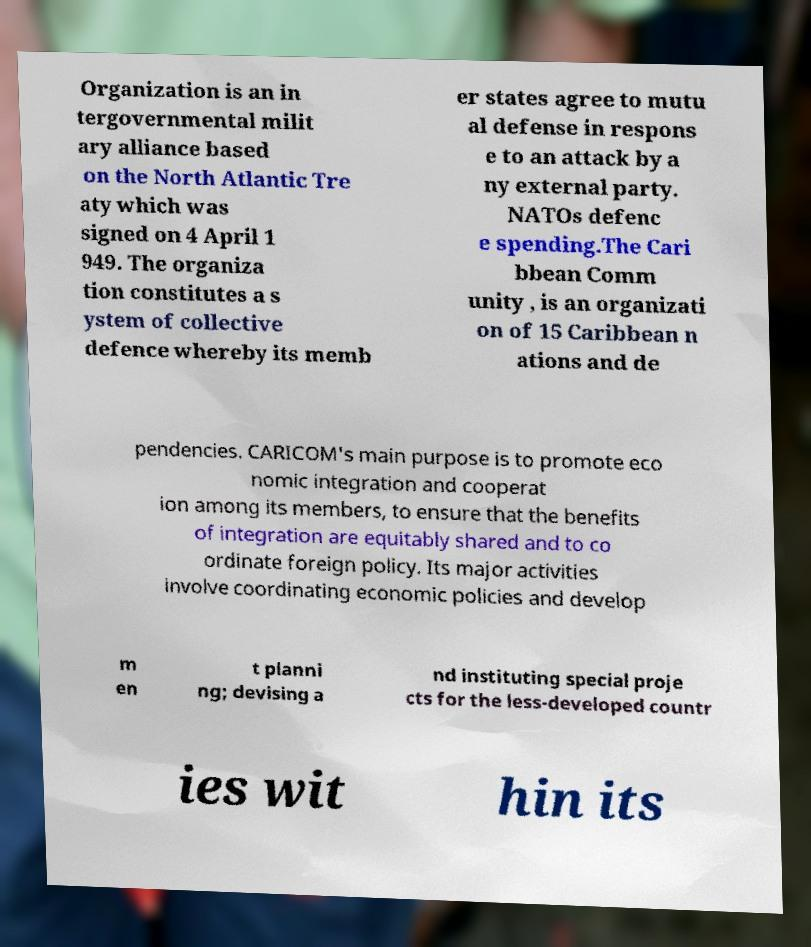Could you extract and type out the text from this image? Organization is an in tergovernmental milit ary alliance based on the North Atlantic Tre aty which was signed on 4 April 1 949. The organiza tion constitutes a s ystem of collective defence whereby its memb er states agree to mutu al defense in respons e to an attack by a ny external party. NATOs defenc e spending.The Cari bbean Comm unity , is an organizati on of 15 Caribbean n ations and de pendencies. CARICOM's main purpose is to promote eco nomic integration and cooperat ion among its members, to ensure that the benefits of integration are equitably shared and to co ordinate foreign policy. Its major activities involve coordinating economic policies and develop m en t planni ng; devising a nd instituting special proje cts for the less-developed countr ies wit hin its 